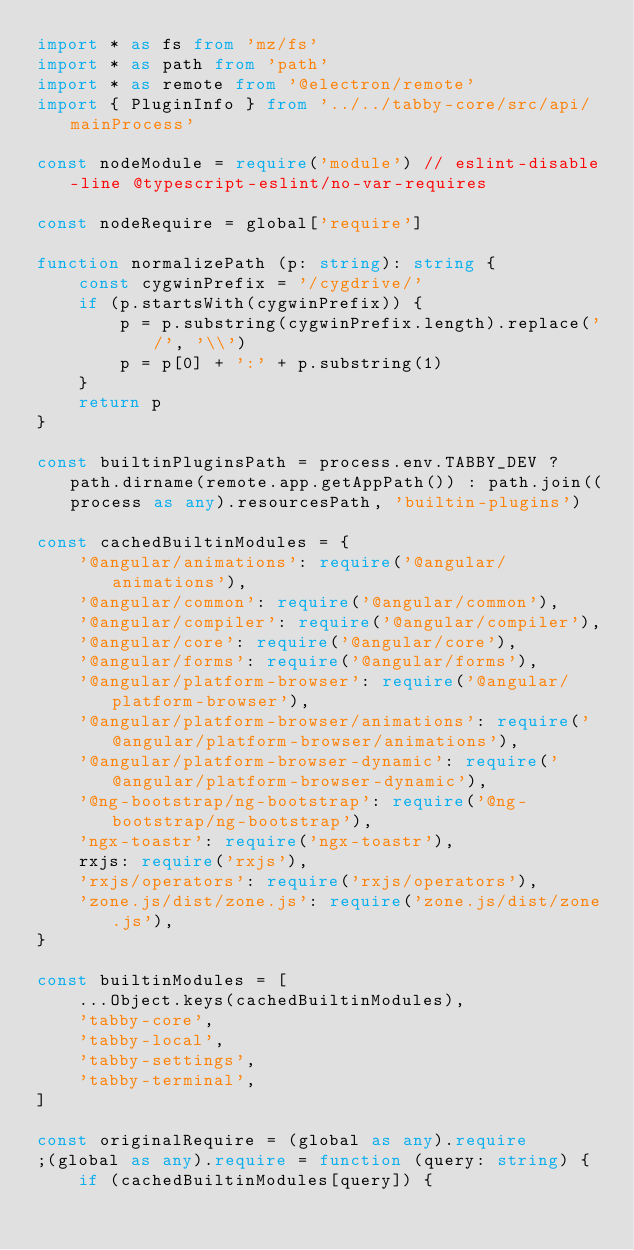Convert code to text. <code><loc_0><loc_0><loc_500><loc_500><_TypeScript_>import * as fs from 'mz/fs'
import * as path from 'path'
import * as remote from '@electron/remote'
import { PluginInfo } from '../../tabby-core/src/api/mainProcess'

const nodeModule = require('module') // eslint-disable-line @typescript-eslint/no-var-requires

const nodeRequire = global['require']

function normalizePath (p: string): string {
    const cygwinPrefix = '/cygdrive/'
    if (p.startsWith(cygwinPrefix)) {
        p = p.substring(cygwinPrefix.length).replace('/', '\\')
        p = p[0] + ':' + p.substring(1)
    }
    return p
}

const builtinPluginsPath = process.env.TABBY_DEV ? path.dirname(remote.app.getAppPath()) : path.join((process as any).resourcesPath, 'builtin-plugins')

const cachedBuiltinModules = {
    '@angular/animations': require('@angular/animations'),
    '@angular/common': require('@angular/common'),
    '@angular/compiler': require('@angular/compiler'),
    '@angular/core': require('@angular/core'),
    '@angular/forms': require('@angular/forms'),
    '@angular/platform-browser': require('@angular/platform-browser'),
    '@angular/platform-browser/animations': require('@angular/platform-browser/animations'),
    '@angular/platform-browser-dynamic': require('@angular/platform-browser-dynamic'),
    '@ng-bootstrap/ng-bootstrap': require('@ng-bootstrap/ng-bootstrap'),
    'ngx-toastr': require('ngx-toastr'),
    rxjs: require('rxjs'),
    'rxjs/operators': require('rxjs/operators'),
    'zone.js/dist/zone.js': require('zone.js/dist/zone.js'),
}

const builtinModules = [
    ...Object.keys(cachedBuiltinModules),
    'tabby-core',
    'tabby-local',
    'tabby-settings',
    'tabby-terminal',
]

const originalRequire = (global as any).require
;(global as any).require = function (query: string) {
    if (cachedBuiltinModules[query]) {</code> 